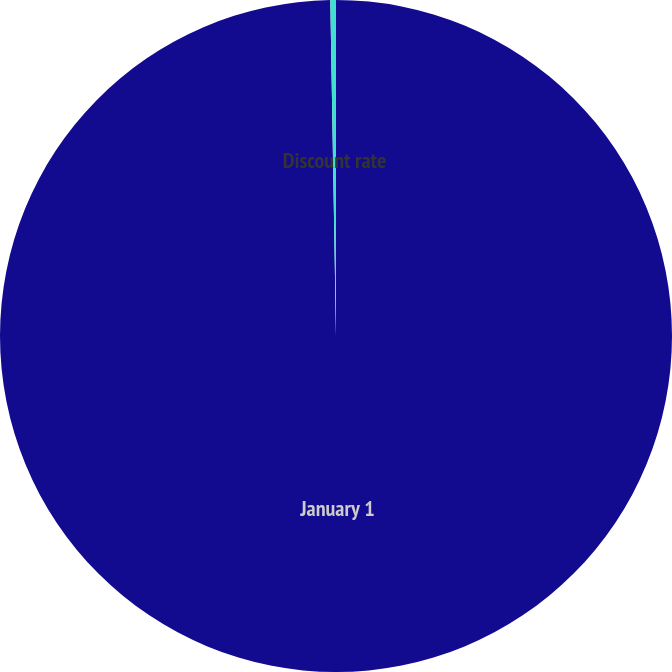Convert chart. <chart><loc_0><loc_0><loc_500><loc_500><pie_chart><fcel>January 1<fcel>Discount rate<nl><fcel>99.73%<fcel>0.27%<nl></chart> 